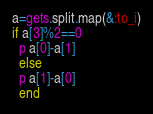Convert code to text. <code><loc_0><loc_0><loc_500><loc_500><_Ruby_>a=gets.split.map(&:to_i)
if a[3]%2==0 
  p a[0]-a[1]
  else
  p a[1]-a[0]
  end</code> 